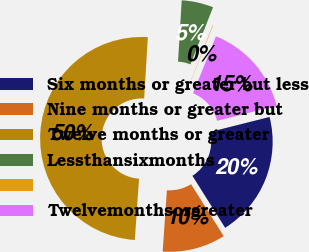Convert chart. <chart><loc_0><loc_0><loc_500><loc_500><pie_chart><fcel>Six months or greater but less<fcel>Nine months or greater but<fcel>Twelve months or greater<fcel>Lessthansixmonths<fcel>Unnamed: 4<fcel>Twelvemonthsorgreater<nl><fcel>19.99%<fcel>10.03%<fcel>49.87%<fcel>5.05%<fcel>0.07%<fcel>15.01%<nl></chart> 